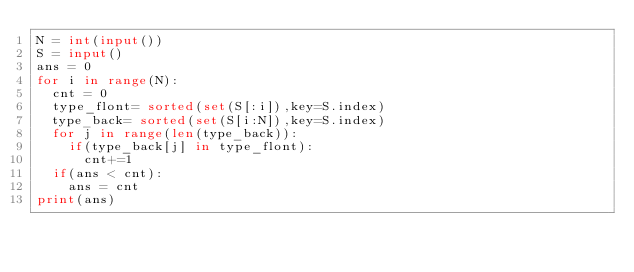<code> <loc_0><loc_0><loc_500><loc_500><_Python_>N = int(input())
S = input()
ans = 0
for i in range(N):
	cnt = 0
	type_flont= sorted(set(S[:i]),key=S.index)
	type_back= sorted(set(S[i:N]),key=S.index)
	for j in range(len(type_back)):
		if(type_back[j] in type_flont):
			cnt+=1
	if(ans < cnt):
		ans = cnt
print(ans)</code> 